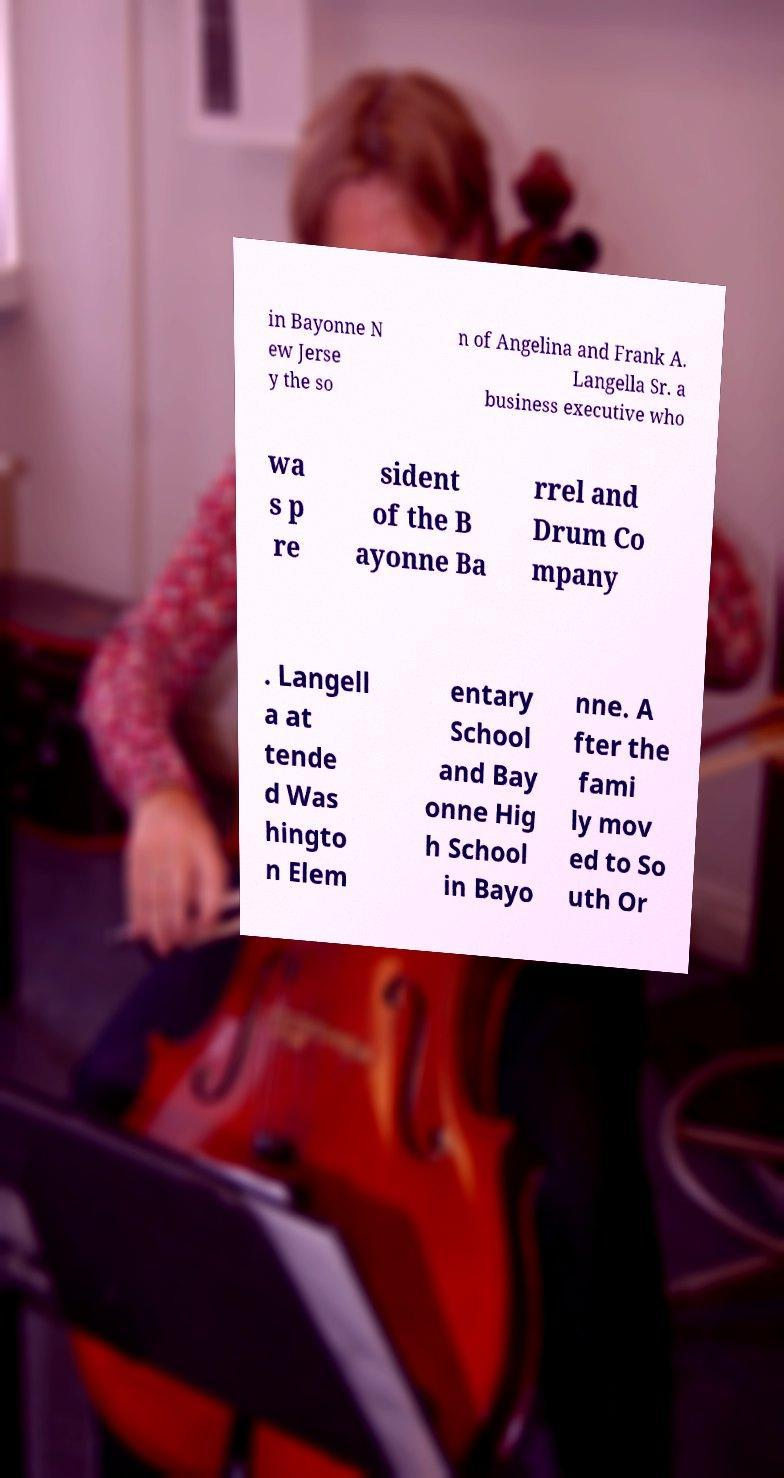Could you extract and type out the text from this image? in Bayonne N ew Jerse y the so n of Angelina and Frank A. Langella Sr. a business executive who wa s p re sident of the B ayonne Ba rrel and Drum Co mpany . Langell a at tende d Was hingto n Elem entary School and Bay onne Hig h School in Bayo nne. A fter the fami ly mov ed to So uth Or 